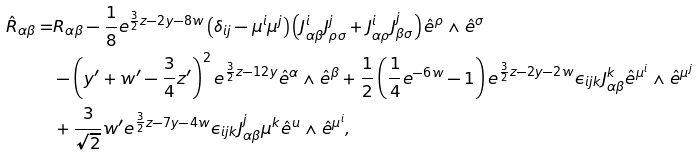Convert formula to latex. <formula><loc_0><loc_0><loc_500><loc_500>\hat { R } _ { \alpha \beta } = & R _ { \alpha \beta } - \frac { 1 } { 8 } e ^ { \frac { 3 } { 2 } z - 2 y - 8 w } \left ( \delta _ { i j } - \mu ^ { i } \mu ^ { j } \right ) \left ( J ^ { i } _ { \alpha \beta } J ^ { j } _ { \rho \sigma } + J ^ { i } _ { \alpha \rho } J ^ { j } _ { \beta \sigma } \right ) \hat { e } ^ { \rho } \wedge \hat { e } ^ { \sigma } \\ & - \left ( y ^ { \prime } + w ^ { \prime } - \frac { 3 } { 4 } z ^ { \prime } \right ) ^ { 2 } e ^ { \frac { 3 } { 2 } z - 1 2 y } \hat { e } ^ { \alpha } \wedge \hat { e } ^ { \beta } + \frac { 1 } { 2 } \left ( \frac { 1 } { 4 } e ^ { - 6 w } - 1 \right ) e ^ { \frac { 3 } { 2 } z - 2 y - 2 w } \epsilon _ { i j k } J ^ { k } _ { \alpha \beta } \hat { e } ^ { \mu ^ { i } } \wedge \hat { e } ^ { \mu ^ { j } } \\ & + \frac { 3 } { \sqrt { 2 } } w ^ { \prime } e ^ { \frac { 3 } { 2 } z - 7 y - 4 w } \epsilon _ { i j k } J ^ { j } _ { \alpha \beta } \mu ^ { k } \hat { e } ^ { u } \wedge \hat { e } ^ { \mu ^ { i } } , \\</formula> 